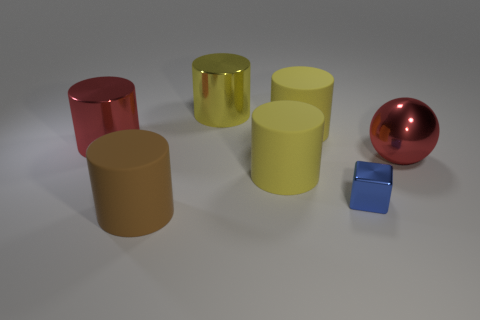How many yellow cylinders must be subtracted to get 1 yellow cylinders? 2 Subtract all blue balls. How many yellow cylinders are left? 3 Subtract 1 cylinders. How many cylinders are left? 4 Subtract all green blocks. Subtract all blue cylinders. How many blocks are left? 1 Add 2 small brown metallic blocks. How many objects exist? 9 Subtract all balls. How many objects are left? 6 Subtract 0 cyan spheres. How many objects are left? 7 Subtract all cylinders. Subtract all big yellow metal balls. How many objects are left? 2 Add 1 red balls. How many red balls are left? 2 Add 7 tiny metal objects. How many tiny metal objects exist? 8 